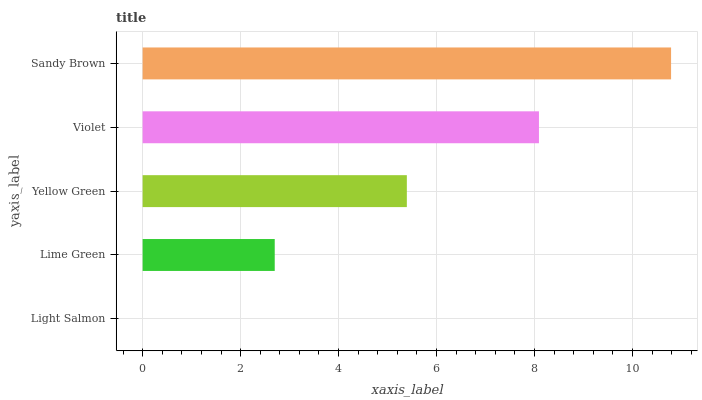Is Light Salmon the minimum?
Answer yes or no. Yes. Is Sandy Brown the maximum?
Answer yes or no. Yes. Is Lime Green the minimum?
Answer yes or no. No. Is Lime Green the maximum?
Answer yes or no. No. Is Lime Green greater than Light Salmon?
Answer yes or no. Yes. Is Light Salmon less than Lime Green?
Answer yes or no. Yes. Is Light Salmon greater than Lime Green?
Answer yes or no. No. Is Lime Green less than Light Salmon?
Answer yes or no. No. Is Yellow Green the high median?
Answer yes or no. Yes. Is Yellow Green the low median?
Answer yes or no. Yes. Is Lime Green the high median?
Answer yes or no. No. Is Violet the low median?
Answer yes or no. No. 